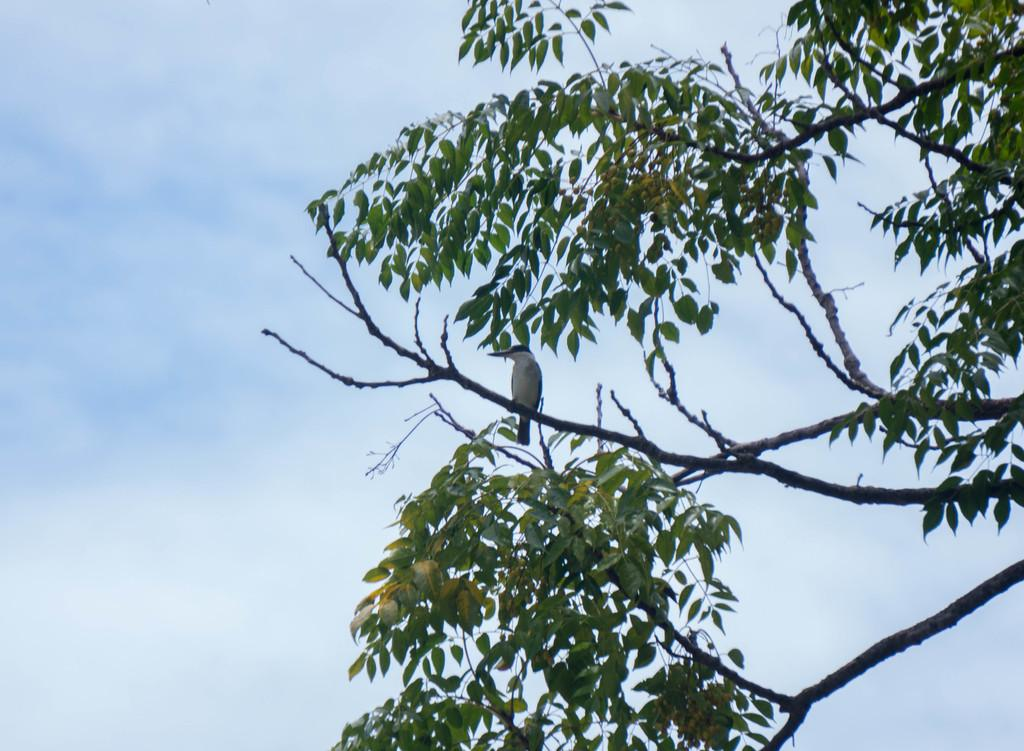What is the condition of the sky in the image? The sky is cloudy in the image. What can be seen on a branch in the image? There is a bird on a branch in the image. What type of vegetation is visible in the image? Leaves and branches are present in the image. How many children are playing with a blade in the image? There are no children or blades present in the image. 